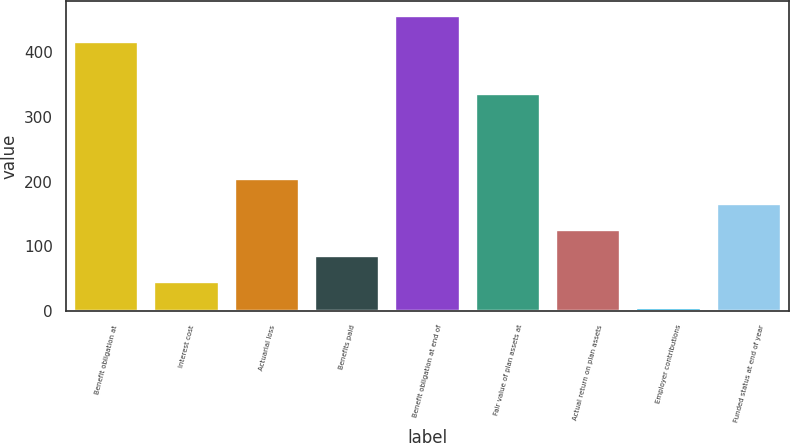Convert chart to OTSL. <chart><loc_0><loc_0><loc_500><loc_500><bar_chart><fcel>Benefit obligation at<fcel>Interest cost<fcel>Actuarial loss<fcel>Benefits paid<fcel>Benefit obligation at end of<fcel>Fair value of plan assets at<fcel>Actual return on plan assets<fcel>Employer contributions<fcel>Funded status at end of year<nl><fcel>415.8<fcel>44.9<fcel>204.5<fcel>84.8<fcel>455.7<fcel>336<fcel>124.7<fcel>5<fcel>164.6<nl></chart> 